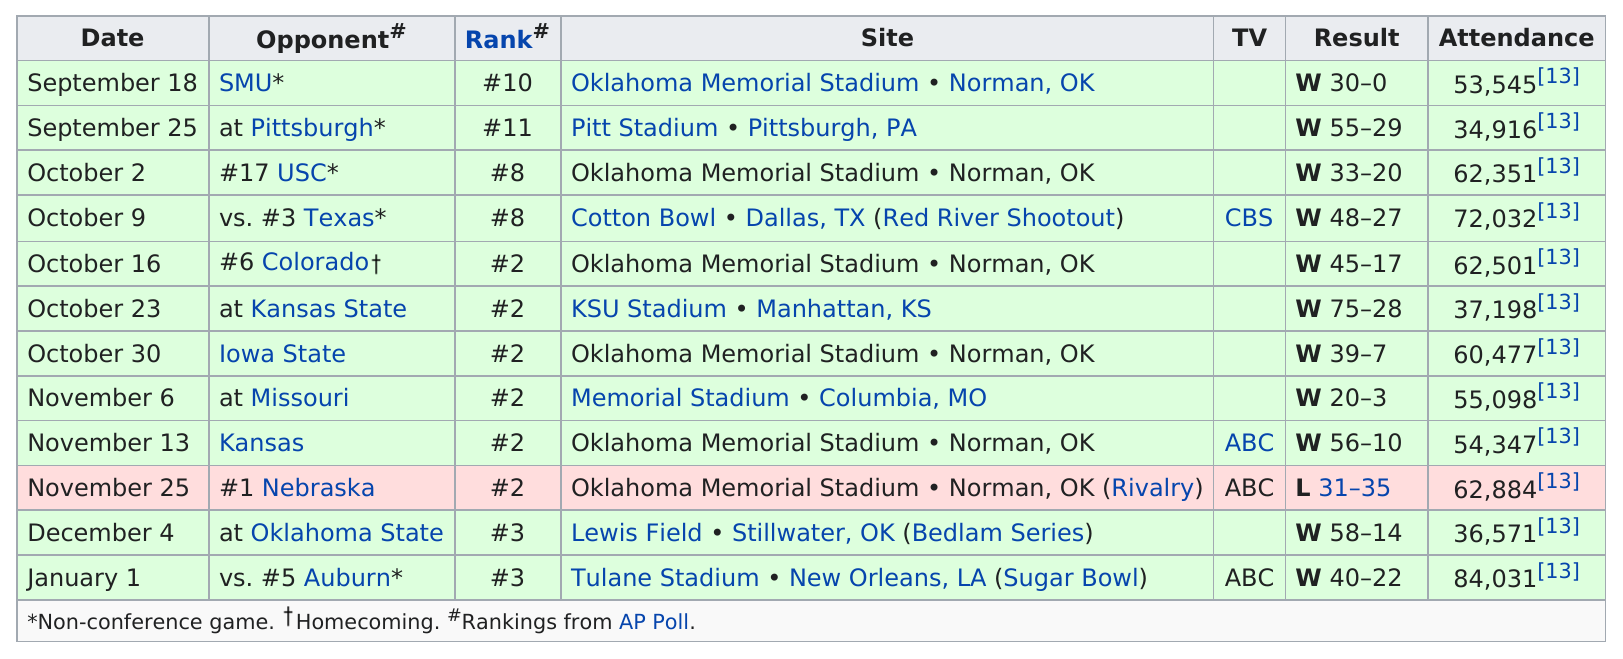Point out several critical features in this image. In each November game that took place, the ranking of the teams was #2. Oklahoma scored more than 50 points against Kansas State. The total attendance for the game against Texas was 72,032. Name an opponent that scored only 7 points. The answer is Iowa State. Approximately two sites had attendance over 70,000. 